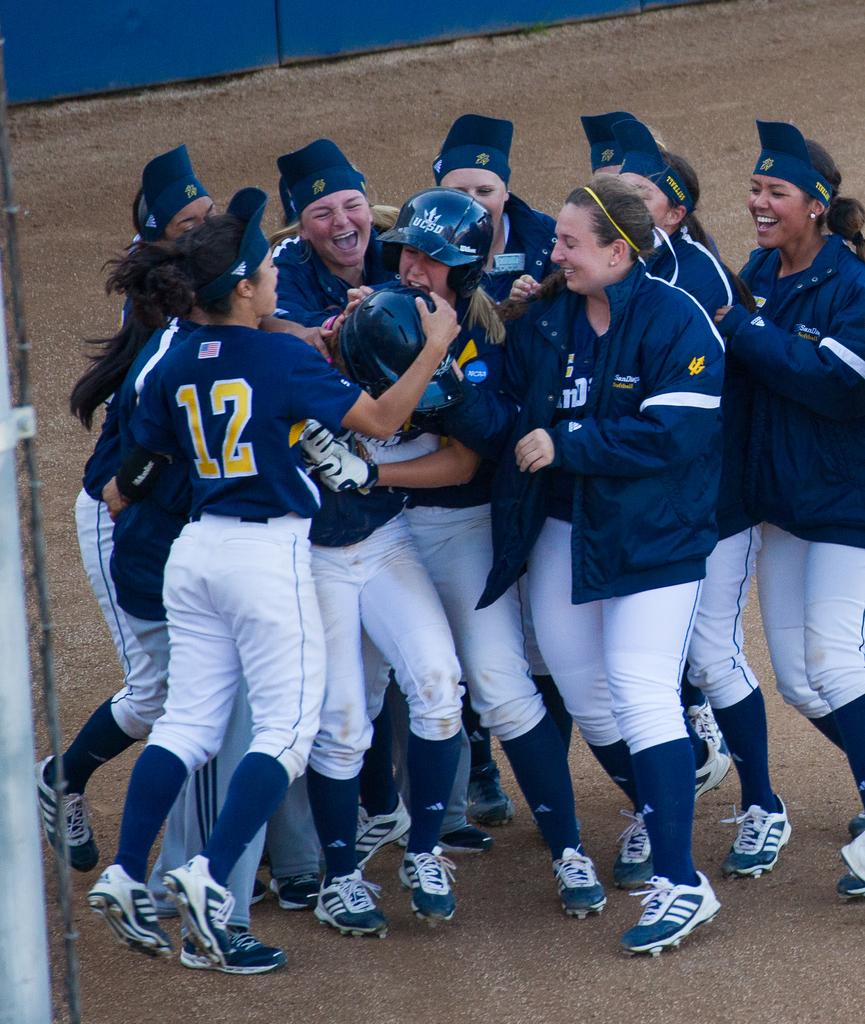<image>
Describe the image concisely. Baseball players including number 12 hugging one another after a victory. 